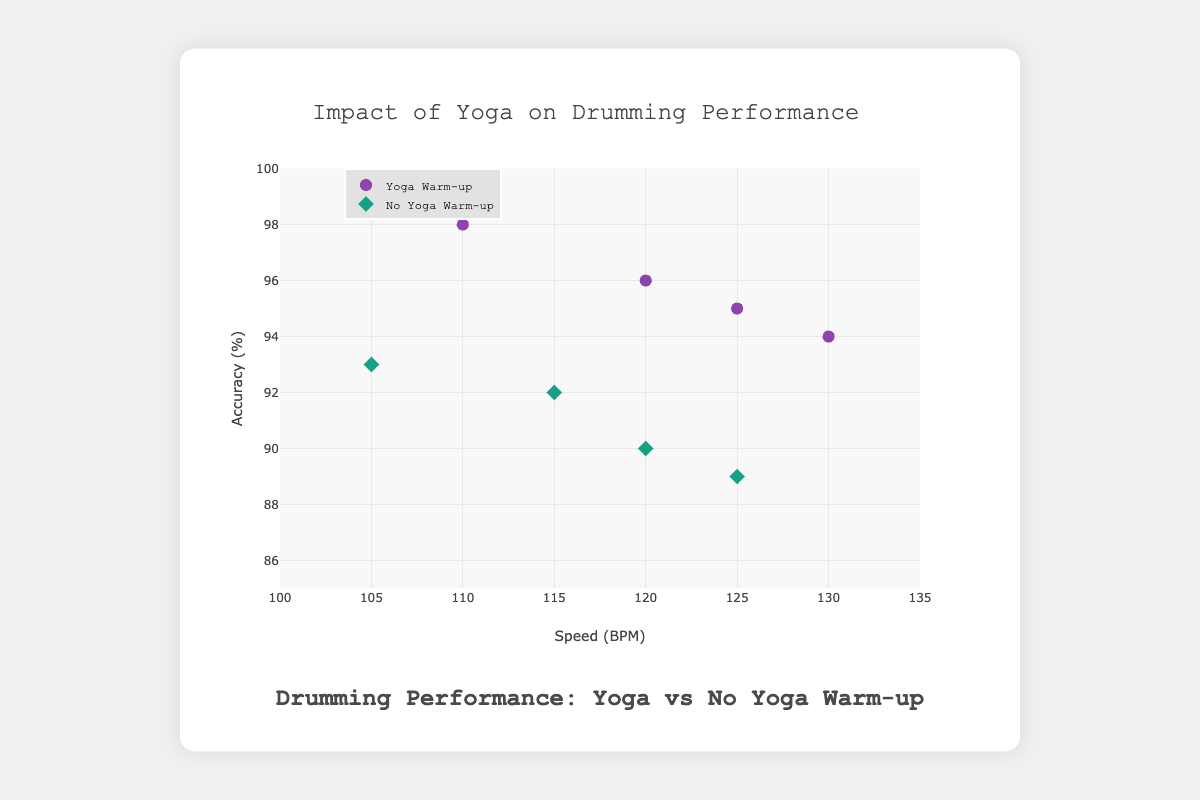Are there more drummers with higher accuracy in yoga or no yoga sessions? The yoga group has accuracy values of 96, 94, 98, and 95, whereas the no yoga group has accuracy values of 92, 89, 93, and 90. All drummers in the yoga group have higher accuracy than in the no yoga group.
Answer: yoga What is the difference in speed between the fastest and the slowest drummer doing yoga? The fastest drummer using yoga is Bob at 130, and the slowest is Charlie at 110. The difference is 130 - 110 = 20 BPM.
Answer: 20 BPM Which drummer experienced the biggest drop in accuracy when not doing yoga? Alice's accuracy drops from 96 (yoga) to 92 (no yoga), a difference of 4. Bob drops from 94 to 89 (5), Charlie drops from 98 to 93 (5), and Donna drops from 95 to 90 (5). Hence, Bob, Charlie, and Donna all experienced the largest drop of 5 points.
Answer: Bob, Charlie, Donna How does the average speed compare between yoga and no yoga groups? Sum of speeds for yoga group: 120 + 130 + 110 + 125 = 485. Number of data points: 4. Average for yoga group: 485 / 4 = 121.25 BPM.
Sum of speeds for no yoga group: 115 + 125 + 105 + 120 = 465. Number of data points: 4. Average for no yoga group: 465 / 4 = 116.25 BPM.
Yoga group has higher average speed.
Answer: Yoga group: 121.25 BPM, No yoga group: 116.25 BPM Which drummer has the highest speed and what warm-up routine did they use? Bob has the highest speed at 130 BPM, which he achieved in the yoga session.
Answer: Bob, yoga What is the range of accuracy scores for the no yoga group? The minimum accuracy score in the no yoga group is 89, and the maximum is 93. Therefore, the range is 93 - 89 = 4%.
Answer: 4% What is the overall trend in accuracy between the yoga and no yoga groups? Each drummer's accuracy is higher in the yoga group compared to the no yoga group. This suggests that yoga positively influences accuracy.
Answer: Yoga positively influences accuracy For which drummer is the impact of yoga on speed the smallest? Alice's speed is 120 with yoga and 115 without, a difference of 5. Bob's difference is also 5 (130 vs 125). Charlie's difference is 5 (110 vs 105). Donna's difference is 5 (125 vs 120). So, the impact is the same across all drummers, with a 5 BPM difference.
Answer: All drummers (5 BPM difference) How many data points are in the figure overall? There are 4 drummers, each with two data points (one for yoga and one for no yoga), amounting to 4 * 2 = 8 data points.
Answer: 8 